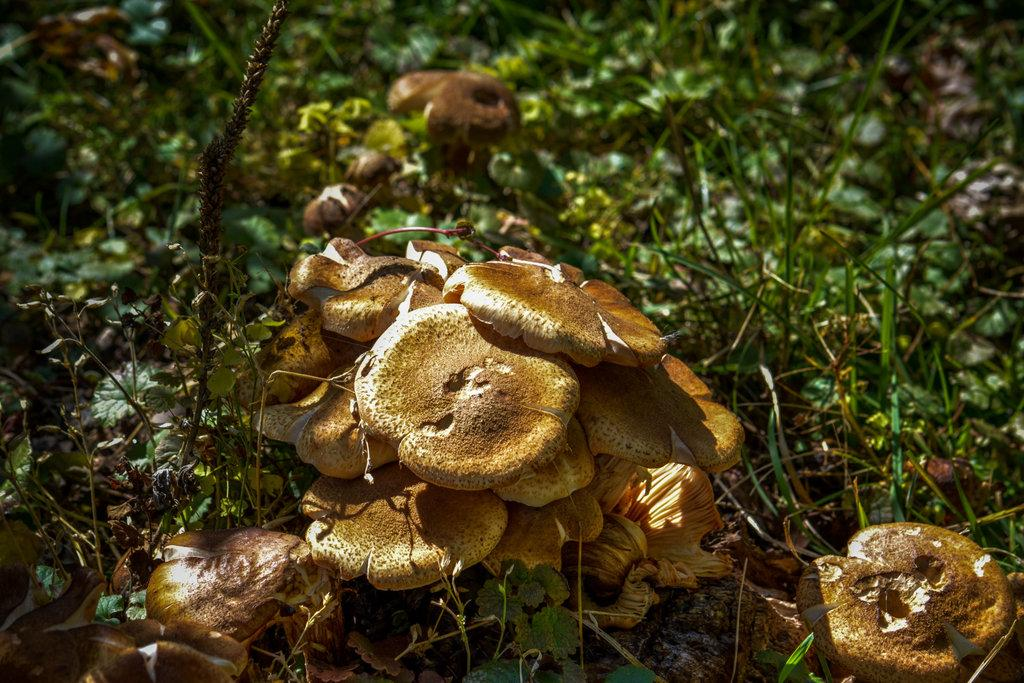What type of vegetation is present in the image? There are mushrooms and grass in the image. Can you describe the environment in the image? The image features a natural environment with mushrooms and grass. What type of sponge can be seen in the image? There is no sponge present in the image; it features mushrooms and grass. What financial interest is represented in the image? The image does not depict any financial interests; it is a natural scene with mushrooms and grass. 